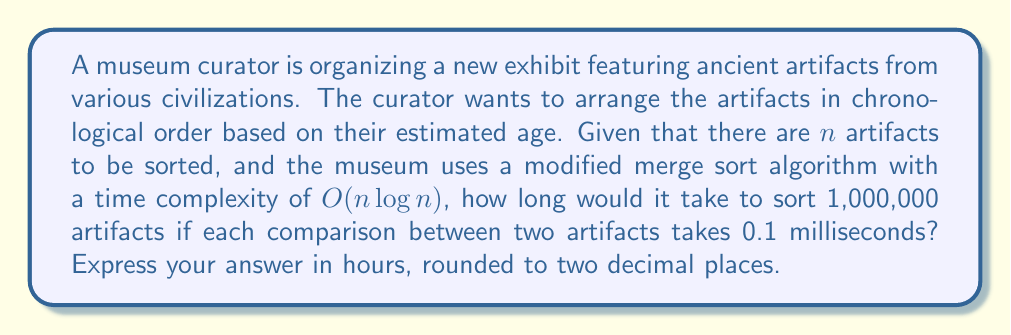Teach me how to tackle this problem. Let's approach this problem step by step:

1) First, we need to calculate the number of comparisons performed by the merge sort algorithm:
   - The time complexity is $O(n \log n)$
   - $n = 1,000,000$
   - Number of comparisons $\approx n \log_2 n = 1,000,000 \times \log_2(1,000,000)$

2) Calculate $\log_2(1,000,000)$:
   $$\log_2(1,000,000) \approx 19.93$$

3) Now, calculate the total number of comparisons:
   $$1,000,000 \times 19.93 \approx 19,930,000$$

4) Each comparison takes 0.1 milliseconds. To find the total time in milliseconds:
   $$19,930,000 \times 0.1 = 1,993,000 \text{ milliseconds}$$

5) Convert milliseconds to seconds:
   $$1,993,000 \text{ ms} = 1,993 \text{ seconds}$$

6) Convert seconds to hours:
   $$1,993 \text{ seconds} = \frac{1,993}{3600} \text{ hours} \approx 0.5536 \text{ hours}$$

7) Rounding to two decimal places:
   $$0.5536 \text{ hours} \approx 0.55 \text{ hours}$$
Answer: 0.55 hours 